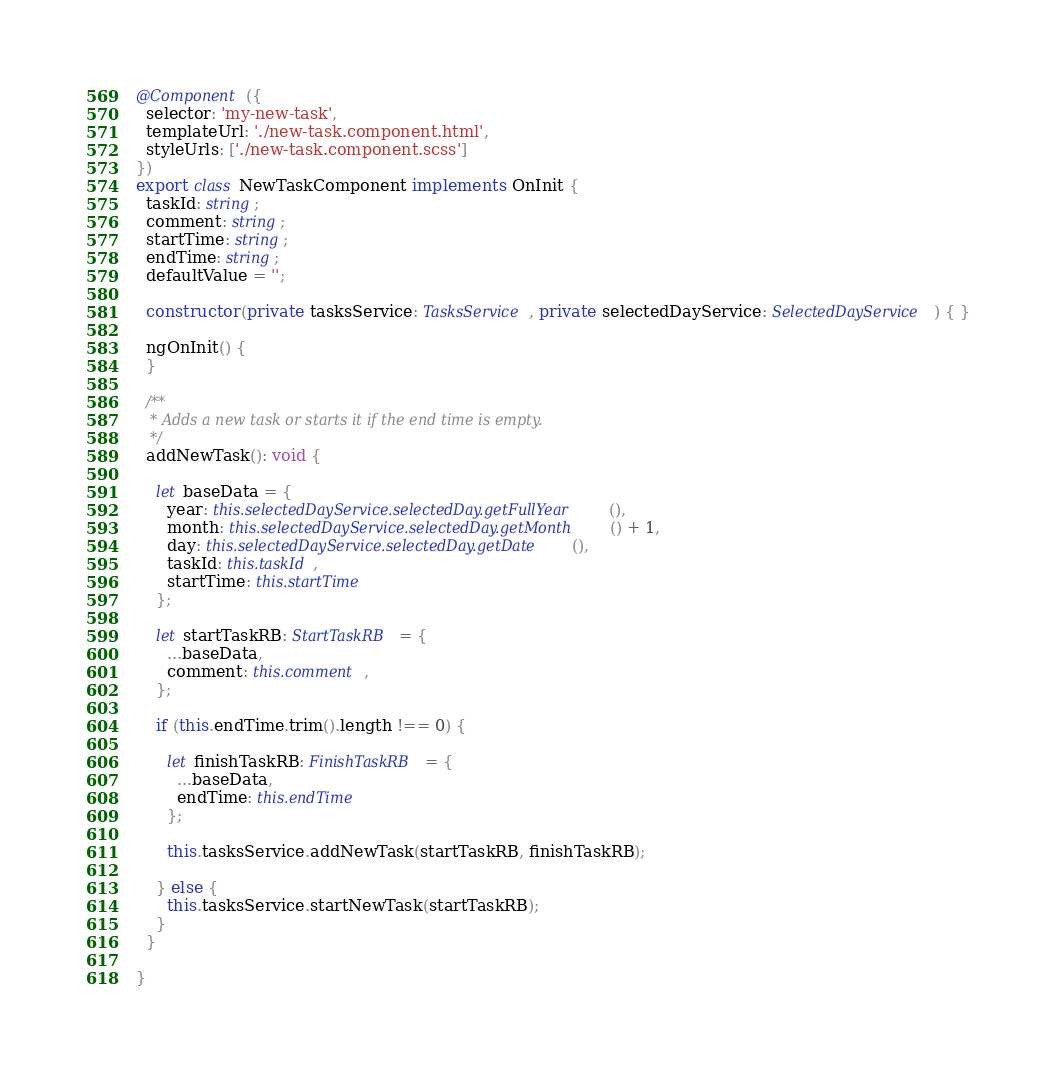<code> <loc_0><loc_0><loc_500><loc_500><_TypeScript_>
@Component({
  selector: 'my-new-task',
  templateUrl: './new-task.component.html',
  styleUrls: ['./new-task.component.scss']
})
export class NewTaskComponent implements OnInit {
  taskId: string;
  comment: string;
  startTime: string;
  endTime: string;
  defaultValue = '';

  constructor(private tasksService: TasksService, private selectedDayService: SelectedDayService) { }

  ngOnInit() {
  }

  /**
   * Adds a new task or starts it if the end time is empty.
   */
  addNewTask(): void {

    let baseData = {
      year: this.selectedDayService.selectedDay.getFullYear(),
      month: this.selectedDayService.selectedDay.getMonth() + 1,
      day: this.selectedDayService.selectedDay.getDate(),
      taskId: this.taskId,
      startTime: this.startTime
    };

    let startTaskRB: StartTaskRB = {
      ...baseData,
      comment: this.comment,
    };

    if (this.endTime.trim().length !== 0) {

      let finishTaskRB: FinishTaskRB = {
        ...baseData,
        endTime: this.endTime
      };

      this.tasksService.addNewTask(startTaskRB, finishTaskRB);

    } else {
      this.tasksService.startNewTask(startTaskRB);
    }
  }

}
</code> 